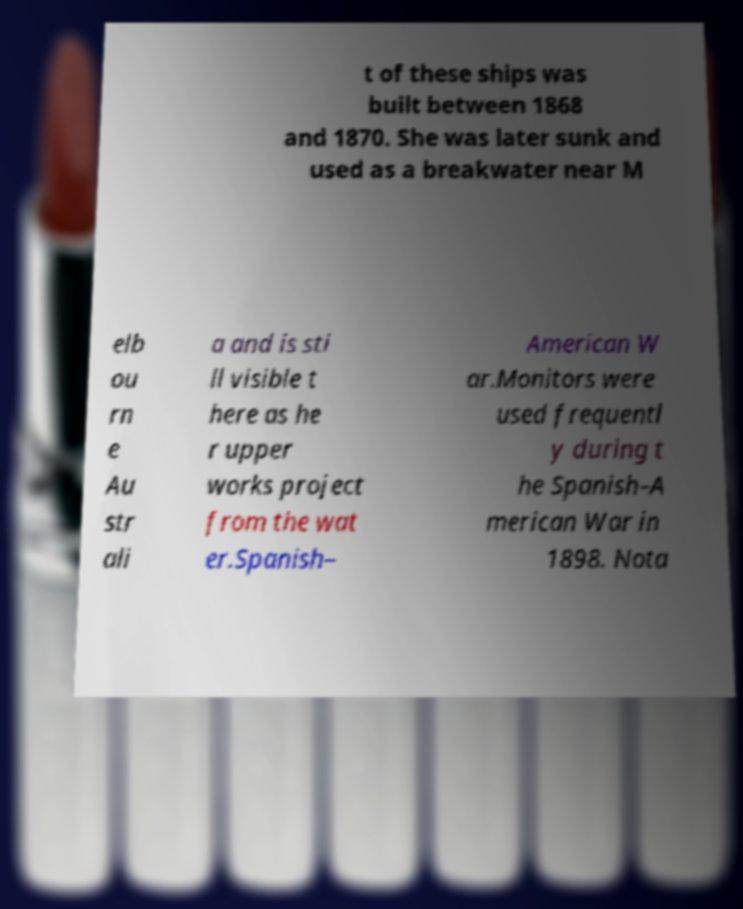Could you assist in decoding the text presented in this image and type it out clearly? t of these ships was built between 1868 and 1870. She was later sunk and used as a breakwater near M elb ou rn e Au str ali a and is sti ll visible t here as he r upper works project from the wat er.Spanish– American W ar.Monitors were used frequentl y during t he Spanish–A merican War in 1898. Nota 